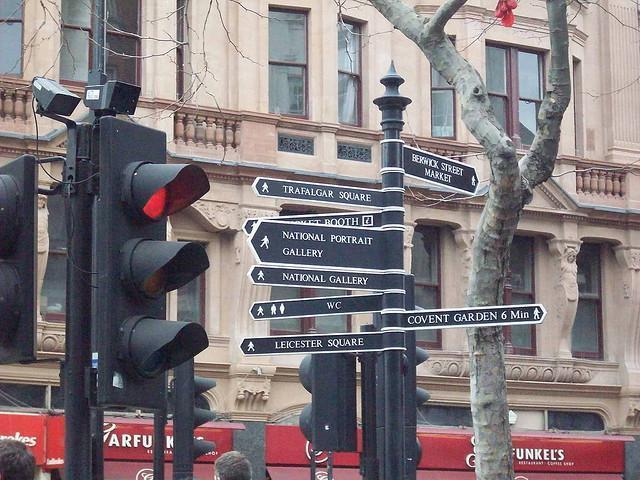How many signs do you see?
Give a very brief answer. 8. How many traffic lights can you see?
Give a very brief answer. 4. How many cars are there with yellow color?
Give a very brief answer. 0. 